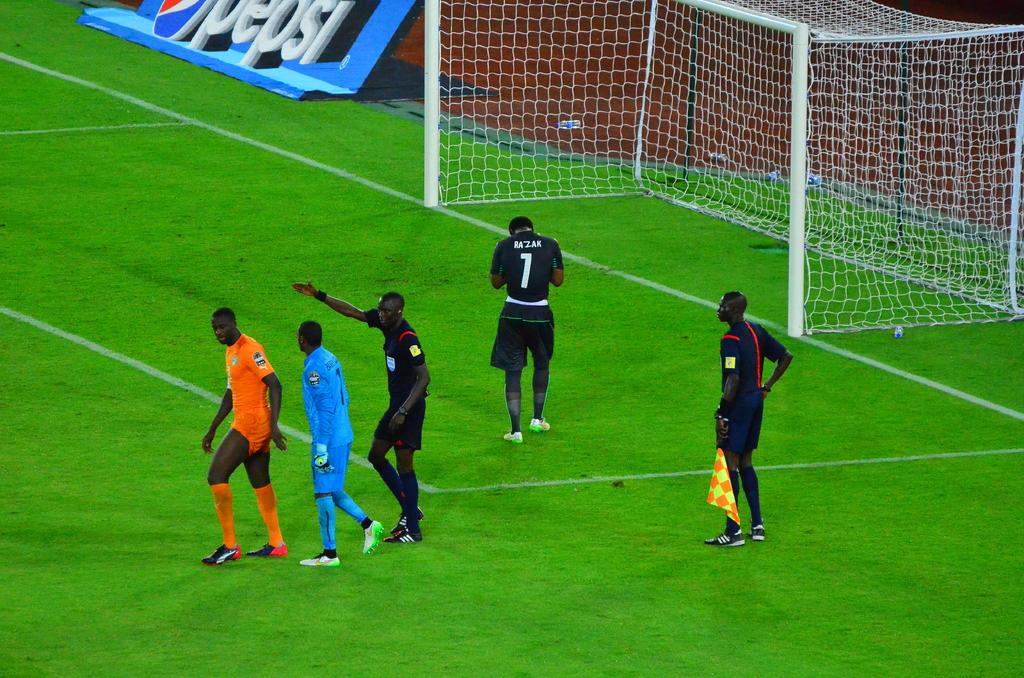<image>
Write a terse but informative summary of the picture. soccer players on a field with a Pepsi sign in the background 